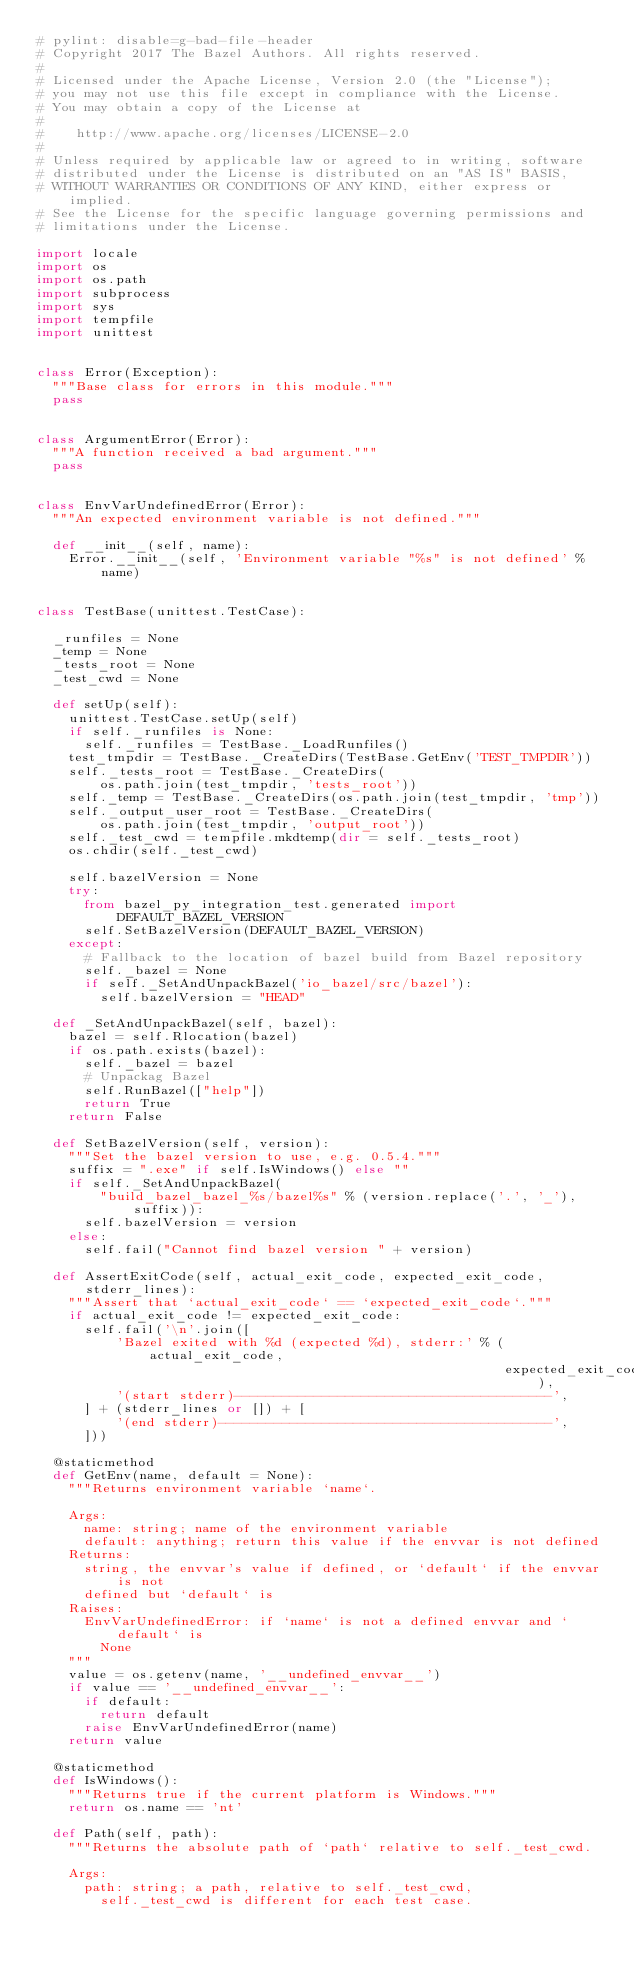<code> <loc_0><loc_0><loc_500><loc_500><_Python_># pylint: disable=g-bad-file-header
# Copyright 2017 The Bazel Authors. All rights reserved.
#
# Licensed under the Apache License, Version 2.0 (the "License");
# you may not use this file except in compliance with the License.
# You may obtain a copy of the License at
#
#    http://www.apache.org/licenses/LICENSE-2.0
#
# Unless required by applicable law or agreed to in writing, software
# distributed under the License is distributed on an "AS IS" BASIS,
# WITHOUT WARRANTIES OR CONDITIONS OF ANY KIND, either express or implied.
# See the License for the specific language governing permissions and
# limitations under the License.

import locale
import os
import os.path
import subprocess
import sys
import tempfile
import unittest


class Error(Exception):
  """Base class for errors in this module."""
  pass


class ArgumentError(Error):
  """A function received a bad argument."""
  pass


class EnvVarUndefinedError(Error):
  """An expected environment variable is not defined."""

  def __init__(self, name):
    Error.__init__(self, 'Environment variable "%s" is not defined' % name)


class TestBase(unittest.TestCase):

  _runfiles = None
  _temp = None
  _tests_root = None
  _test_cwd = None

  def setUp(self):
    unittest.TestCase.setUp(self)
    if self._runfiles is None:
      self._runfiles = TestBase._LoadRunfiles()
    test_tmpdir = TestBase._CreateDirs(TestBase.GetEnv('TEST_TMPDIR'))
    self._tests_root = TestBase._CreateDirs(
        os.path.join(test_tmpdir, 'tests_root'))
    self._temp = TestBase._CreateDirs(os.path.join(test_tmpdir, 'tmp'))
    self._output_user_root = TestBase._CreateDirs(
        os.path.join(test_tmpdir, 'output_root'))
    self._test_cwd = tempfile.mkdtemp(dir = self._tests_root)
    os.chdir(self._test_cwd)

    self.bazelVersion = None
    try:
      from bazel_py_integration_test.generated import DEFAULT_BAZEL_VERSION
      self.SetBazelVersion(DEFAULT_BAZEL_VERSION)
    except:
      # Fallback to the location of bazel build from Bazel repository
      self._bazel = None
      if self._SetAndUnpackBazel('io_bazel/src/bazel'):
        self.bazelVersion = "HEAD"

  def _SetAndUnpackBazel(self, bazel):
    bazel = self.Rlocation(bazel)
    if os.path.exists(bazel):
      self._bazel = bazel
      # Unpackag Bazel
      self.RunBazel(["help"])
      return True
    return False

  def SetBazelVersion(self, version):
    """Set the bazel version to use, e.g. 0.5.4."""
    suffix = ".exe" if self.IsWindows() else ""
    if self._SetAndUnpackBazel(
        "build_bazel_bazel_%s/bazel%s" % (version.replace('.', '_'), suffix)):
      self.bazelVersion = version
    else:
      self.fail("Cannot find bazel version " + version)

  def AssertExitCode(self, actual_exit_code, expected_exit_code, stderr_lines):
    """Assert that `actual_exit_code` == `expected_exit_code`."""
    if actual_exit_code != expected_exit_code:
      self.fail('\n'.join([
          'Bazel exited with %d (expected %d), stderr:' % (actual_exit_code,
                                                           expected_exit_code),
          '(start stderr)----------------------------------------',
      ] + (stderr_lines or []) + [
          '(end stderr)------------------------------------------',
      ]))

  @staticmethod
  def GetEnv(name, default = None):
    """Returns environment variable `name`.

    Args:
      name: string; name of the environment variable
      default: anything; return this value if the envvar is not defined
    Returns:
      string, the envvar's value if defined, or `default` if the envvar is not
      defined but `default` is
    Raises:
      EnvVarUndefinedError: if `name` is not a defined envvar and `default` is
        None
    """
    value = os.getenv(name, '__undefined_envvar__')
    if value == '__undefined_envvar__':
      if default:
        return default
      raise EnvVarUndefinedError(name)
    return value

  @staticmethod
  def IsWindows():
    """Returns true if the current platform is Windows."""
    return os.name == 'nt'

  def Path(self, path):
    """Returns the absolute path of `path` relative to self._test_cwd.

    Args:
      path: string; a path, relative to self._test_cwd,
        self._test_cwd is different for each test case.</code> 